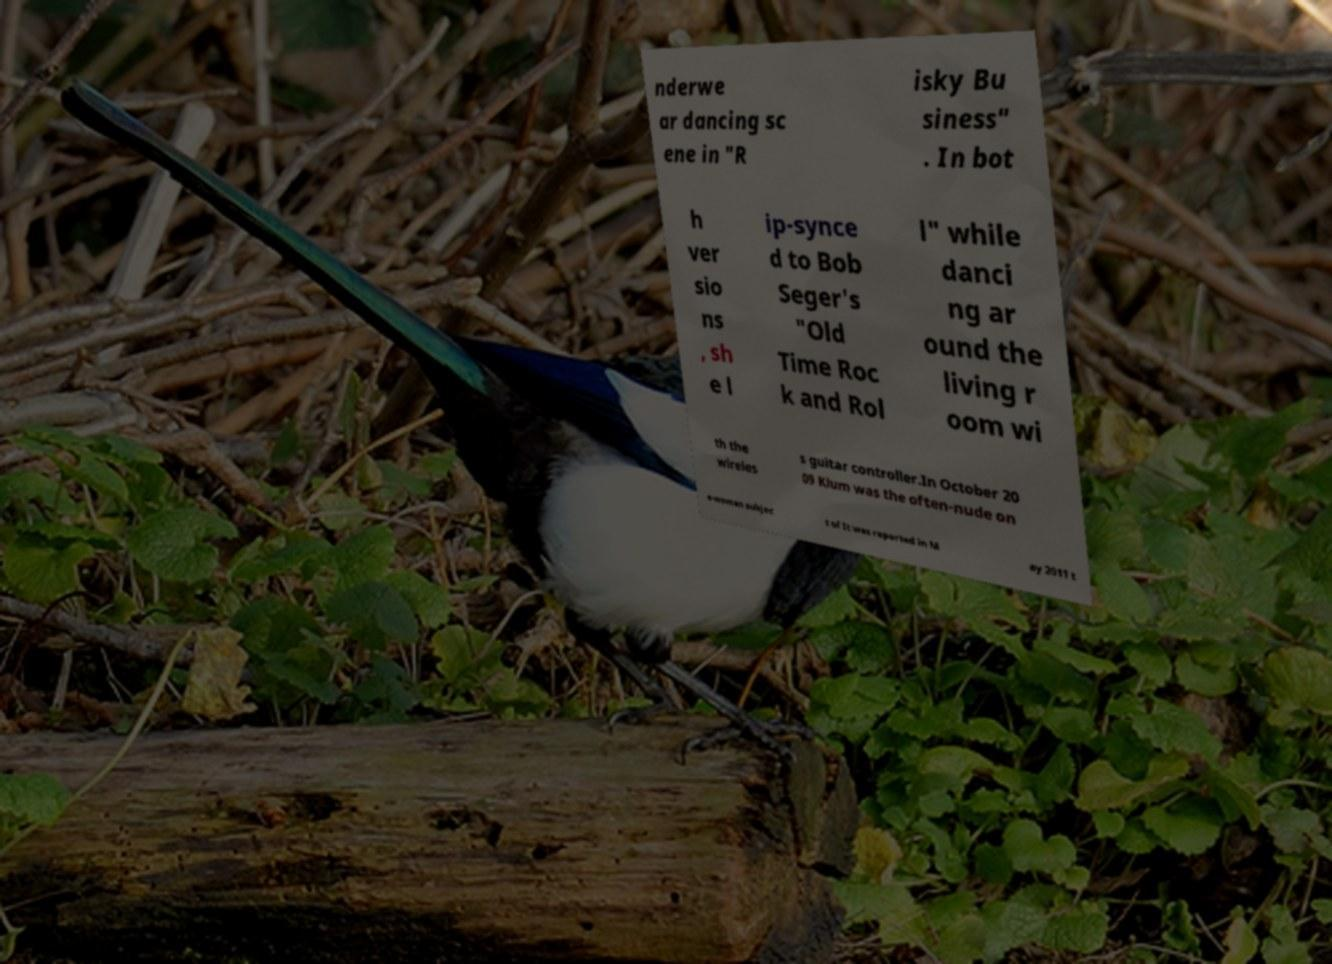There's text embedded in this image that I need extracted. Can you transcribe it verbatim? nderwe ar dancing sc ene in "R isky Bu siness" . In bot h ver sio ns , sh e l ip-synce d to Bob Seger's "Old Time Roc k and Rol l" while danci ng ar ound the living r oom wi th the wireles s guitar controller.In October 20 09 Klum was the often-nude on e-woman subjec t of It was reported in M ay 2011 t 